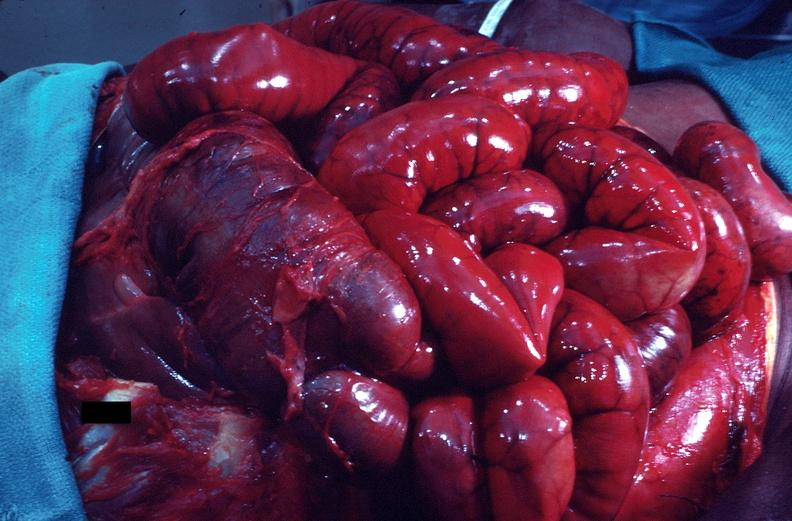what does this image show?
Answer the question using a single word or phrase. Intestine in situ 